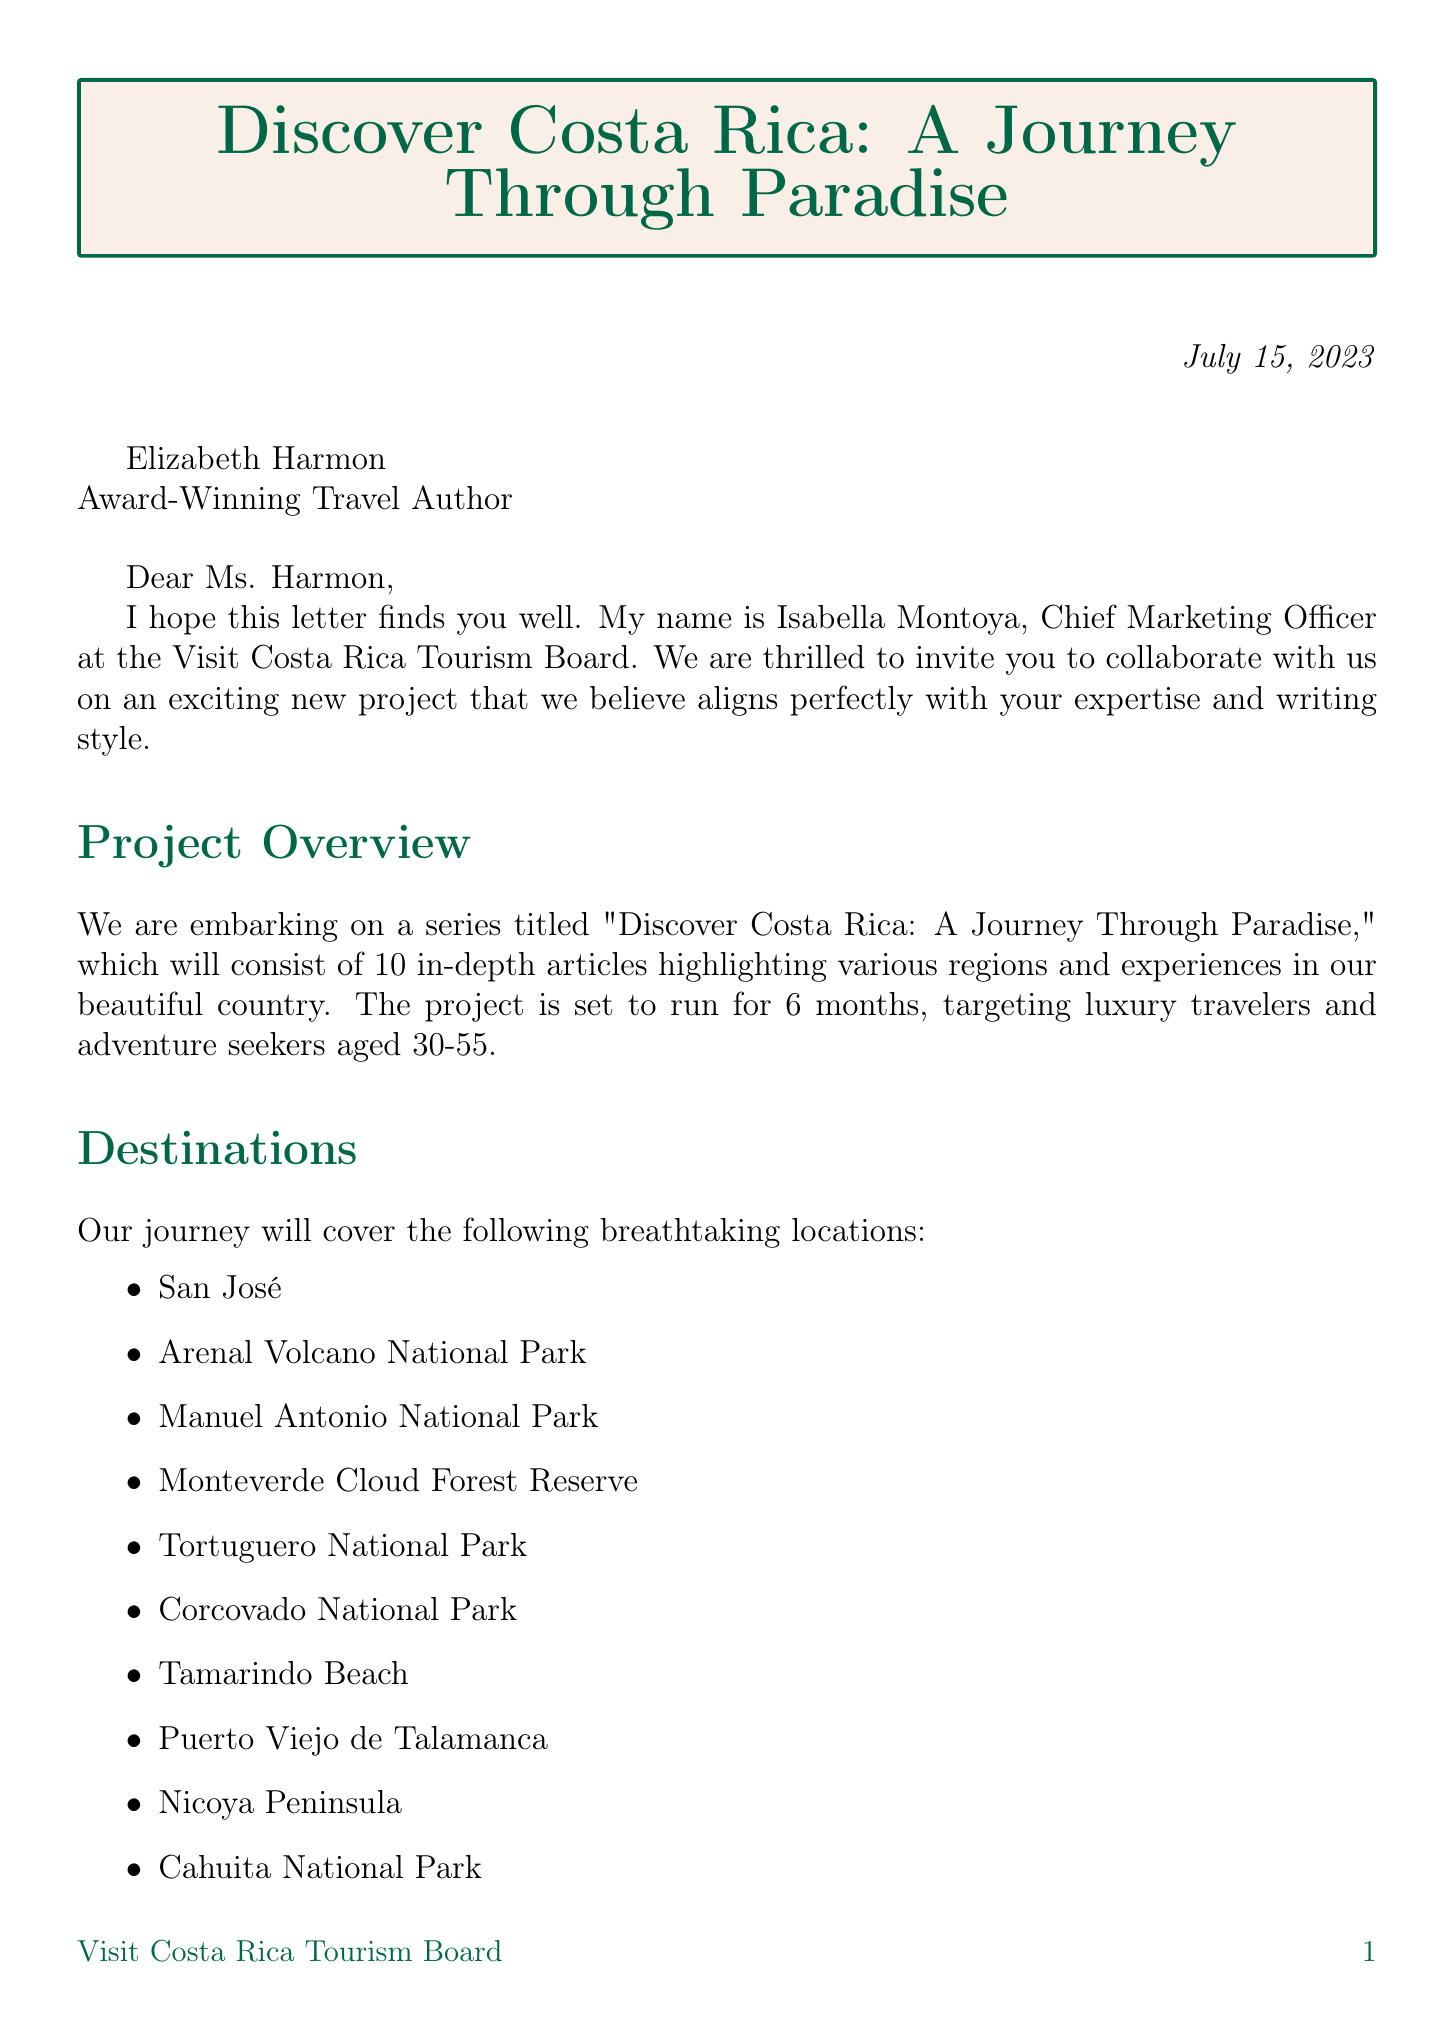What is the name of the sender? The sender's name is mentioned in the letter as Isabella Montoya.
Answer: Isabella Montoya What is the title of the project? The title of the project is "Discover Costa Rica: A Journey Through Paradise."
Answer: Discover Costa Rica: A Journey Through Paradise How many articles are to be written? The document states that the project will consist of 10 in-depth articles.
Answer: 10 What is the base rate compensation per article? The base rate compensation is clearly stated in the letter as $2,500 per article.
Answer: $2,500 What is the duration of the project? The letter specifies that the duration of the project is 6 months.
Answer: 6 months Which destination is mentioned first in the list? The first destination mentioned in the list is San José.
Answer: San José How often should articles be submitted? The frequency of article submission is specified as bi-weekly in the document.
Answer: Bi-weekly What additional collaboration opportunity is offered? The letter mentions "Input on itinerary planning" as an additional collaboration opportunity.
Answer: Input on itinerary planning What type of travelers is the target audience? The target audience is defined as luxury travelers and adventure seekers aged 30-55.
Answer: Luxury travelers and adventure seekers aged 30-55 